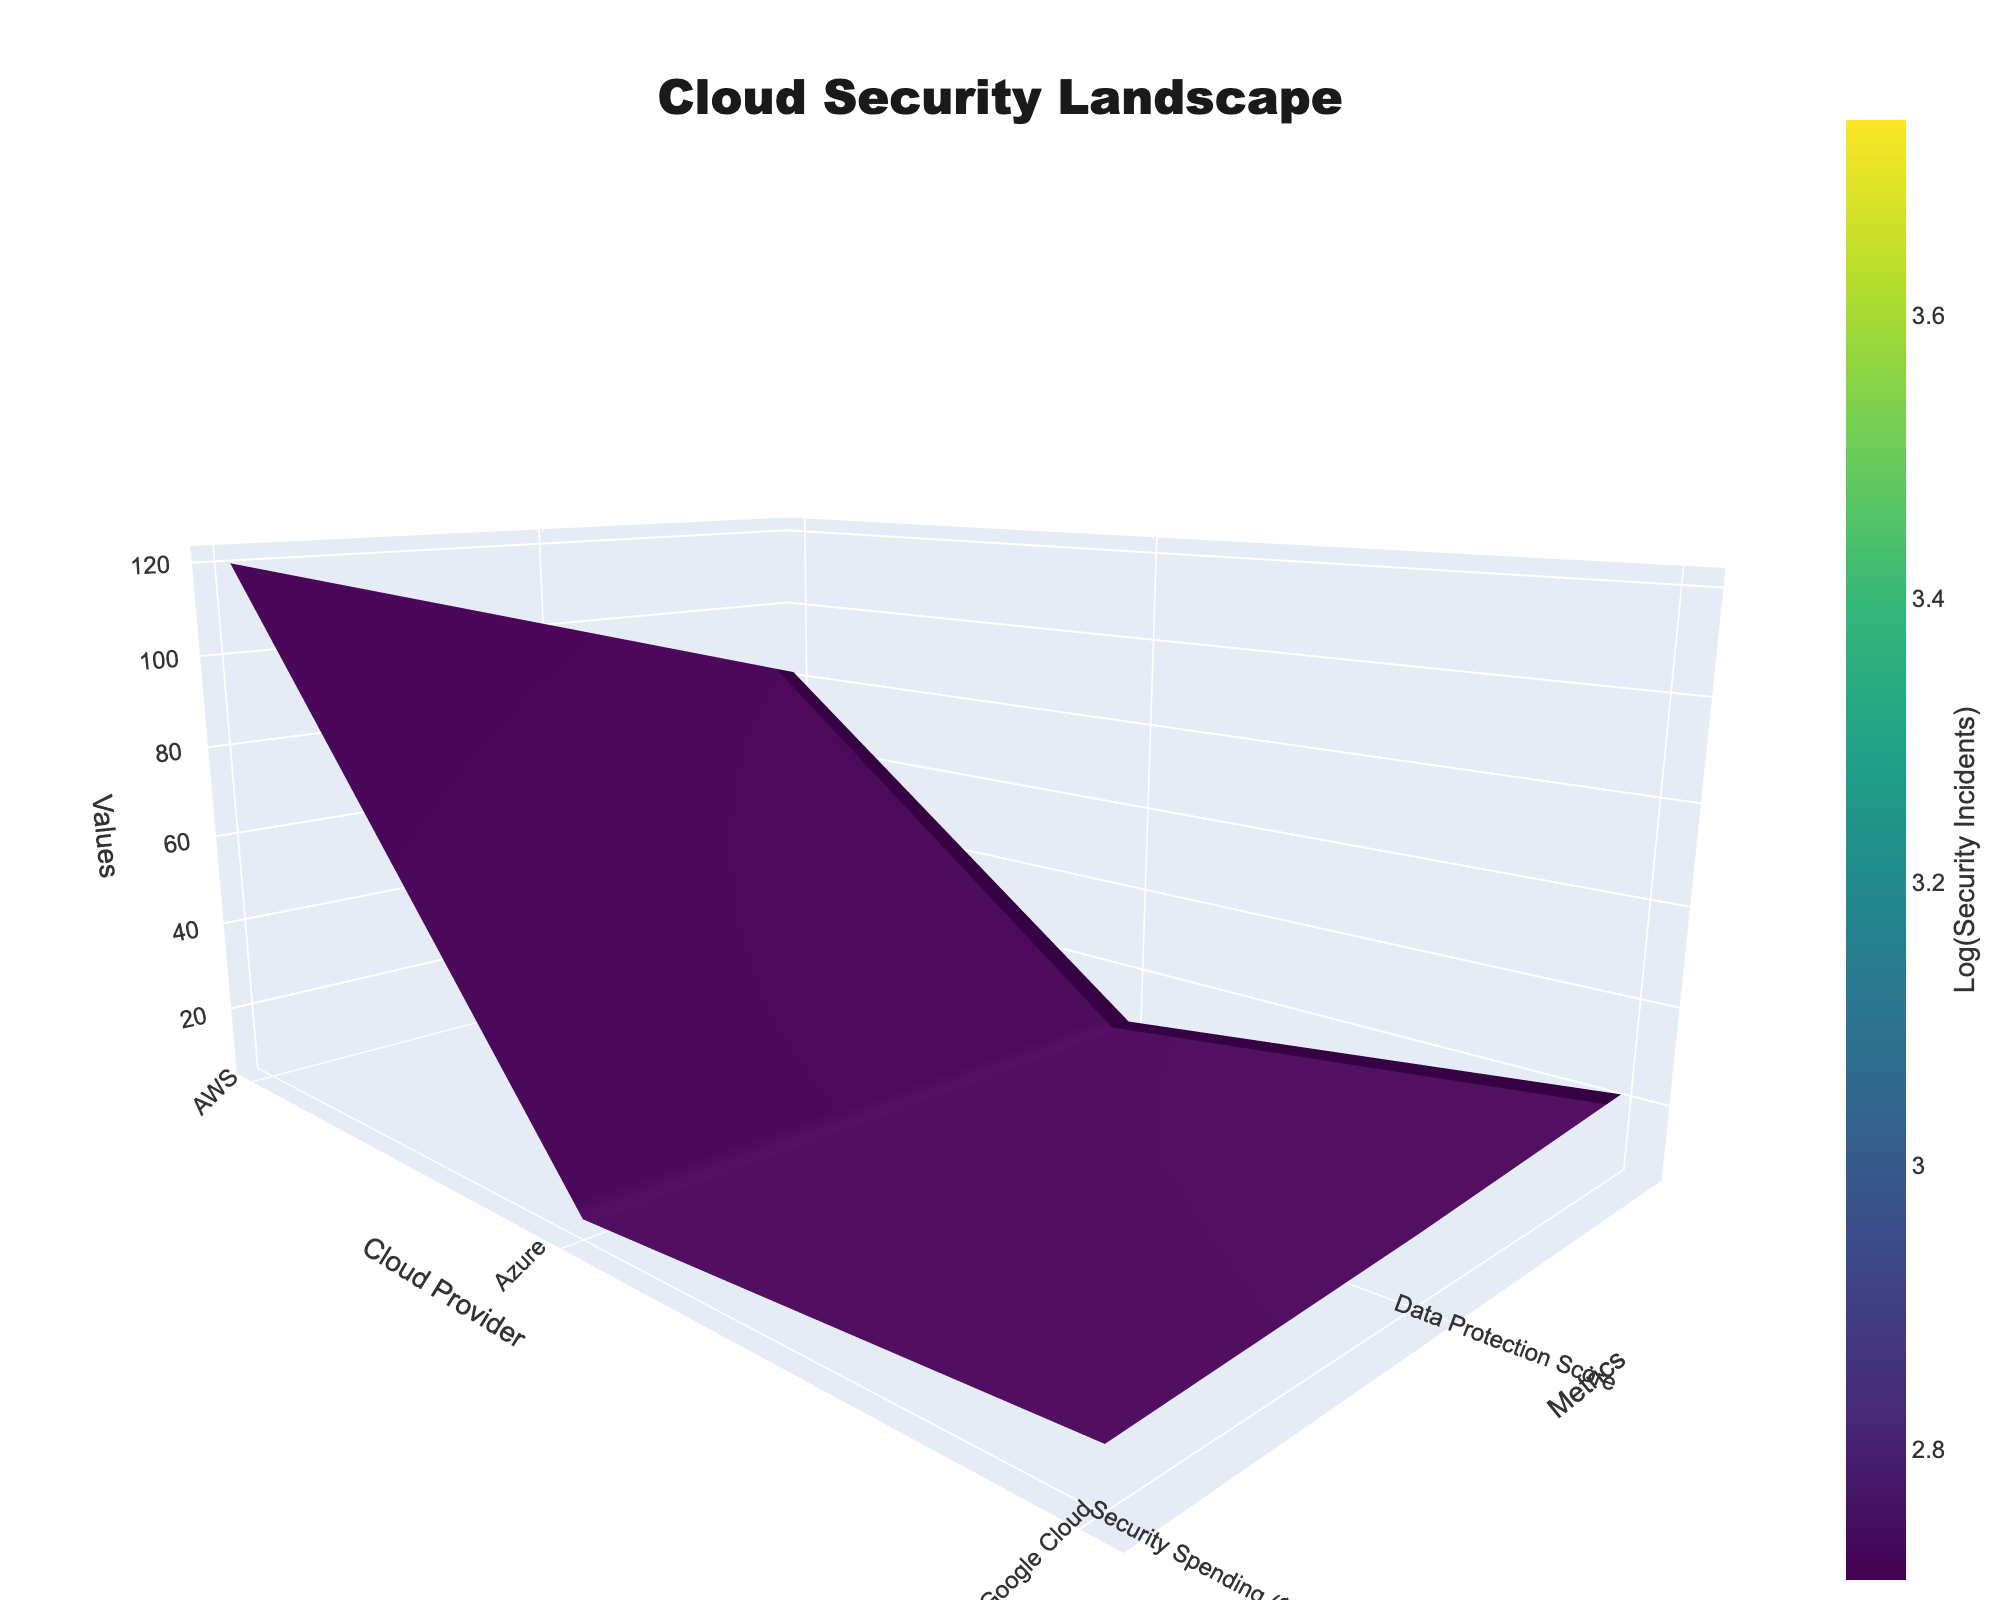What is the title of the figure? The title is displayed at the top center of the plot. It sets the context for the visualized data. The title reads "Cloud Security Landscape" which tells us that the figure represents data related to cloud security.
Answer: Cloud Security Landscape Which cloud provider shows the highest security spending? Looking at the surface plot, the z-axis shows the value for different metrics including security spending. The cloud provider with the peak at the highest z-coordinate for security spending is AWS.
Answer: AWS Compare the data protection scores of Google Cloud and IBM Cloud. By observing the surface plot, you can see that Google Cloud has a higher data protection score compared to IBM Cloud. This is evident as Google Cloud's value on the y-axis for data protection is higher.
Answer: Google Cloud has a higher data protection score than IBM Cloud What metric values are associated with Salesforce in the plot? Moving along the surface plot to identify Salesforce on the x-axis, you can read off the values for the y-axis (Metrics) and the corresponding z-coordinates. Salesforce has a security spending of $15M, a data protection score of 6.0, and 42 security incidents.
Answer: $15M spending, 6.0 data protection score, 42 security incidents How does security incident count relate to security spending overall? Observing the colors of the surface plot, which are based on the logarithm of security incidents, you can notice that higher security spending often corresponds to lower counts of security incidents. This trend is visible as areas with higher z-coordinates (security spending) often have colors representing lower values of security incidents.
Answer: Higher spending generally relates to fewer incidents Which cloud provider has the lowest data protection score, and what is its value? By identifying the lowest point on the y-axis for data protection scores and matching it with the x-axis (cloud provider), we see that Salesforce has the lowest data protection score of 6.0.
Answer: Salesforce with a score of 6.0 Rank AWS, Azure, and Google Cloud based on their security incident rates. By reading the z-values for security incidents across these providers on the surface plot, you find AWS has 15, Azure has 18, and Google Cloud has 22 security incidents. Thus, the ranking from fewest to most incidents is AWS, Azure, Google Cloud.
Answer: AWS < Azure < Google Cloud What is the difference in security spending between AWS and Oracle Cloud? The surface plot shows AWS's security spending is $120M, and Oracle Cloud's security spending is $50M. The difference between these values is $120M - $50M = $70M.
Answer: $70M What does the color legend on the right side of the plot represent? The color legend on the figure indicates it represents the logarithm of security incidents, which maps the color intensity to the count of security incidents. This helps in understanding the relative severity of security incidents across different providers visually.
Answer: Logarithm of security incidents 